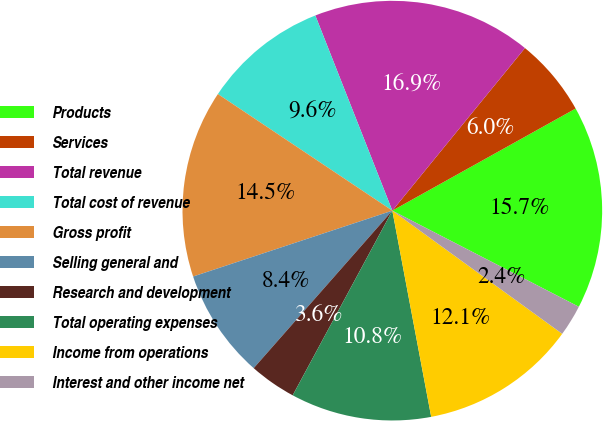<chart> <loc_0><loc_0><loc_500><loc_500><pie_chart><fcel>Products<fcel>Services<fcel>Total revenue<fcel>Total cost of revenue<fcel>Gross profit<fcel>Selling general and<fcel>Research and development<fcel>Total operating expenses<fcel>Income from operations<fcel>Interest and other income net<nl><fcel>15.66%<fcel>6.02%<fcel>16.87%<fcel>9.64%<fcel>14.46%<fcel>8.43%<fcel>3.61%<fcel>10.84%<fcel>12.05%<fcel>2.41%<nl></chart> 